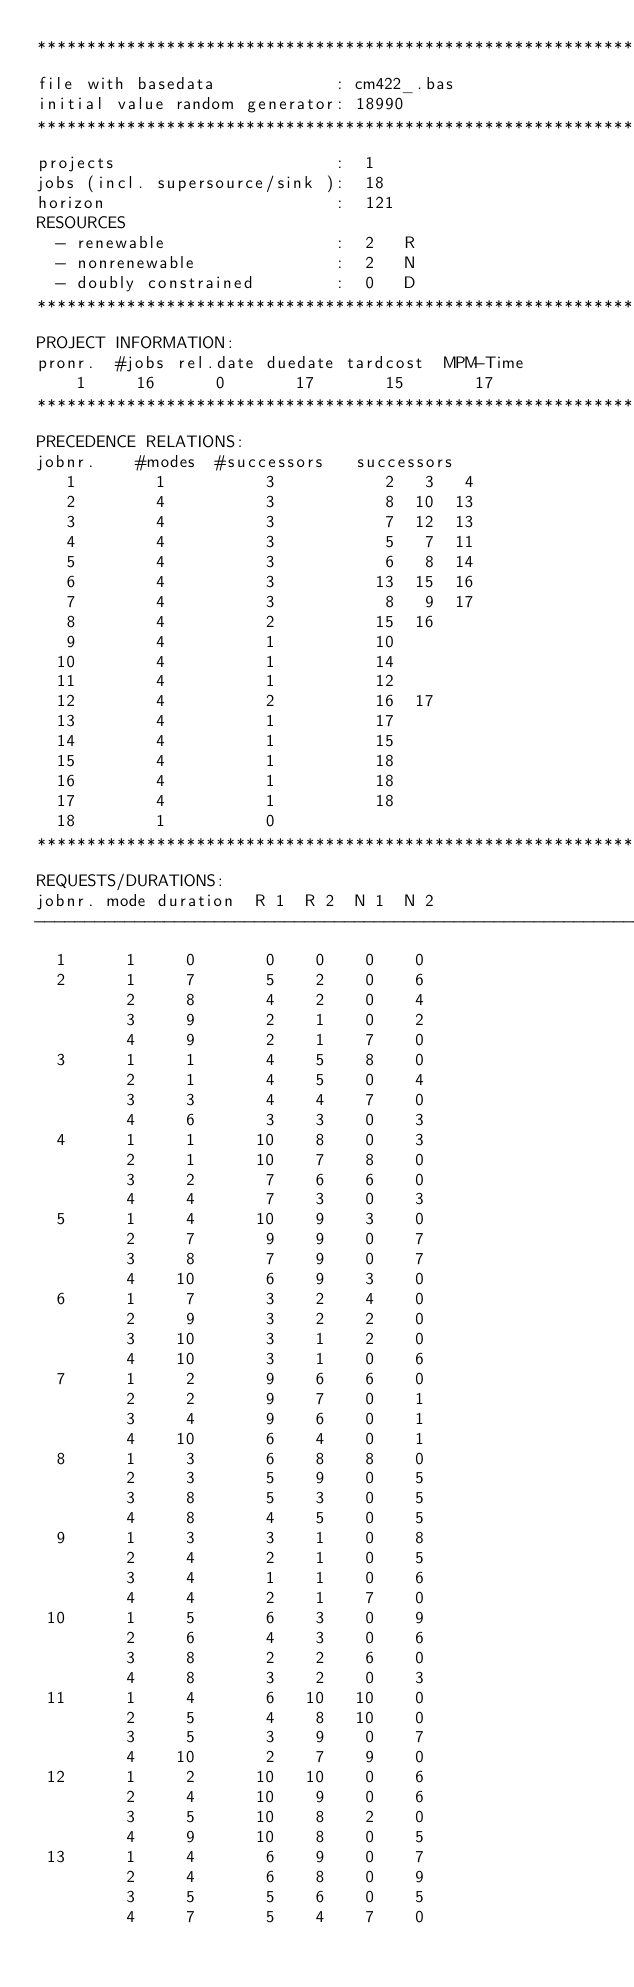Convert code to text. <code><loc_0><loc_0><loc_500><loc_500><_ObjectiveC_>************************************************************************
file with basedata            : cm422_.bas
initial value random generator: 18990
************************************************************************
projects                      :  1
jobs (incl. supersource/sink ):  18
horizon                       :  121
RESOURCES
  - renewable                 :  2   R
  - nonrenewable              :  2   N
  - doubly constrained        :  0   D
************************************************************************
PROJECT INFORMATION:
pronr.  #jobs rel.date duedate tardcost  MPM-Time
    1     16      0       17       15       17
************************************************************************
PRECEDENCE RELATIONS:
jobnr.    #modes  #successors   successors
   1        1          3           2   3   4
   2        4          3           8  10  13
   3        4          3           7  12  13
   4        4          3           5   7  11
   5        4          3           6   8  14
   6        4          3          13  15  16
   7        4          3           8   9  17
   8        4          2          15  16
   9        4          1          10
  10        4          1          14
  11        4          1          12
  12        4          2          16  17
  13        4          1          17
  14        4          1          15
  15        4          1          18
  16        4          1          18
  17        4          1          18
  18        1          0        
************************************************************************
REQUESTS/DURATIONS:
jobnr. mode duration  R 1  R 2  N 1  N 2
------------------------------------------------------------------------
  1      1     0       0    0    0    0
  2      1     7       5    2    0    6
         2     8       4    2    0    4
         3     9       2    1    0    2
         4     9       2    1    7    0
  3      1     1       4    5    8    0
         2     1       4    5    0    4
         3     3       4    4    7    0
         4     6       3    3    0    3
  4      1     1      10    8    0    3
         2     1      10    7    8    0
         3     2       7    6    6    0
         4     4       7    3    0    3
  5      1     4      10    9    3    0
         2     7       9    9    0    7
         3     8       7    9    0    7
         4    10       6    9    3    0
  6      1     7       3    2    4    0
         2     9       3    2    2    0
         3    10       3    1    2    0
         4    10       3    1    0    6
  7      1     2       9    6    6    0
         2     2       9    7    0    1
         3     4       9    6    0    1
         4    10       6    4    0    1
  8      1     3       6    8    8    0
         2     3       5    9    0    5
         3     8       5    3    0    5
         4     8       4    5    0    5
  9      1     3       3    1    0    8
         2     4       2    1    0    5
         3     4       1    1    0    6
         4     4       2    1    7    0
 10      1     5       6    3    0    9
         2     6       4    3    0    6
         3     8       2    2    6    0
         4     8       3    2    0    3
 11      1     4       6   10   10    0
         2     5       4    8   10    0
         3     5       3    9    0    7
         4    10       2    7    9    0
 12      1     2      10   10    0    6
         2     4      10    9    0    6
         3     5      10    8    2    0
         4     9      10    8    0    5
 13      1     4       6    9    0    7
         2     4       6    8    0    9
         3     5       5    6    0    5
         4     7       5    4    7    0</code> 